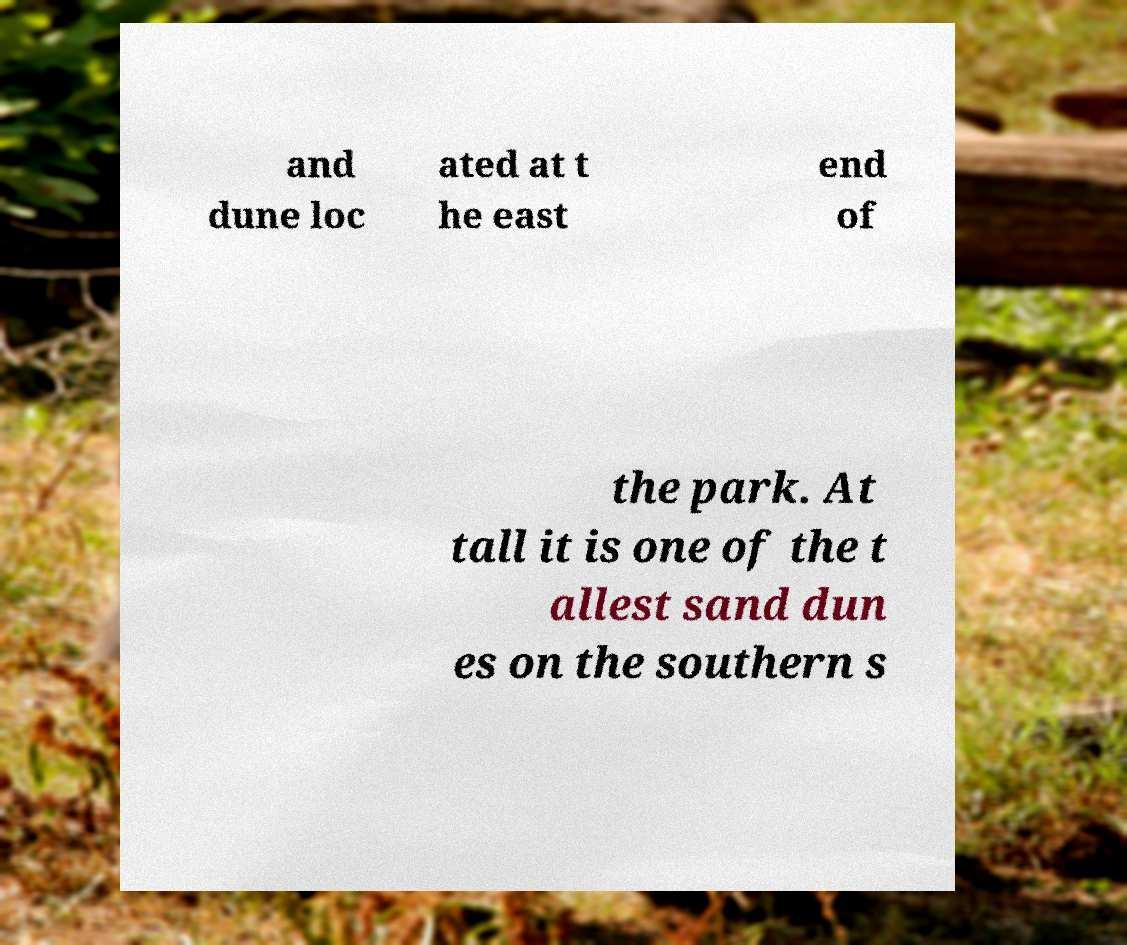There's text embedded in this image that I need extracted. Can you transcribe it verbatim? and dune loc ated at t he east end of the park. At tall it is one of the t allest sand dun es on the southern s 